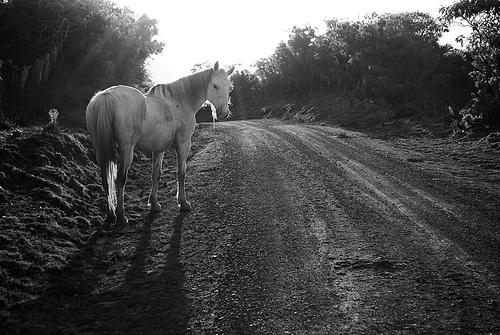Is this picture from pre 1900?
Concise answer only. No. What is on the road?
Answer briefly. Horse. Are these people following too close behind these elephants?
Write a very short answer. No. Is this a horse or elephant?
Write a very short answer. Horse. 